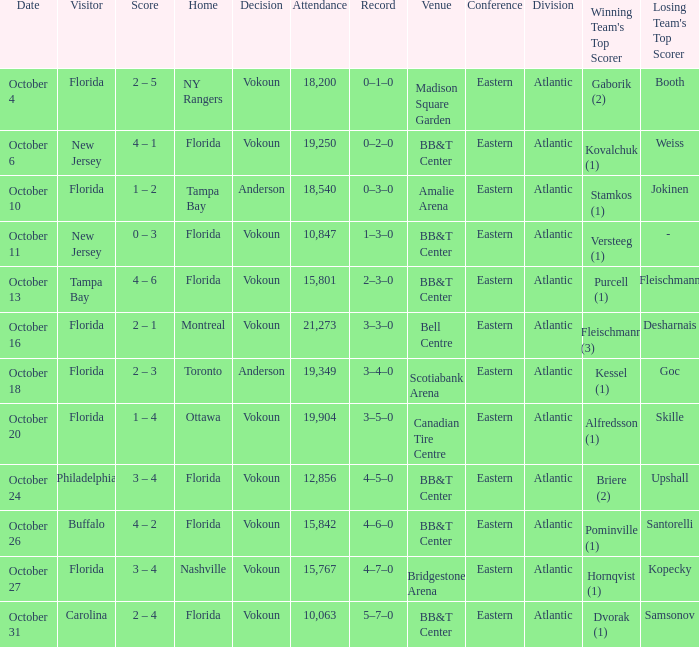Parse the table in full. {'header': ['Date', 'Visitor', 'Score', 'Home', 'Decision', 'Attendance', 'Record', 'Venue', 'Conference', 'Division', "Winning Team's Top Scorer", "Losing Team's Top Scorer"], 'rows': [['October 4', 'Florida', '2 – 5', 'NY Rangers', 'Vokoun', '18,200', '0–1–0', 'Madison Square Garden', 'Eastern', 'Atlantic', 'Gaborik (2)', 'Booth'], ['October 6', 'New Jersey', '4 – 1', 'Florida', 'Vokoun', '19,250', '0–2–0', 'BB&T Center', 'Eastern', 'Atlantic', 'Kovalchuk (1)', 'Weiss'], ['October 10', 'Florida', '1 – 2', 'Tampa Bay', 'Anderson', '18,540', '0–3–0', 'Amalie Arena', 'Eastern', 'Atlantic', 'Stamkos (1)', 'Jokinen'], ['October 11', 'New Jersey', '0 – 3', 'Florida', 'Vokoun', '10,847', '1–3–0', 'BB&T Center', 'Eastern', 'Atlantic', 'Versteeg (1)', '- '], ['October 13', 'Tampa Bay', '4 – 6', 'Florida', 'Vokoun', '15,801', '2–3–0', 'BB&T Center', 'Eastern', 'Atlantic', 'Purcell (1)', 'Fleischmann'], ['October 16', 'Florida', '2 – 1', 'Montreal', 'Vokoun', '21,273', '3–3–0', 'Bell Centre', 'Eastern', 'Atlantic', 'Fleischmann (3)', 'Desharnais'], ['October 18', 'Florida', '2 – 3', 'Toronto', 'Anderson', '19,349', '3–4–0', 'Scotiabank Arena', 'Eastern', 'Atlantic', 'Kessel (1)', 'Goc'], ['October 20', 'Florida', '1 – 4', 'Ottawa', 'Vokoun', '19,904', '3–5–0', 'Canadian Tire Centre', 'Eastern', 'Atlantic', 'Alfredsson (1)', 'Skille'], ['October 24', 'Philadelphia', '3 – 4', 'Florida', 'Vokoun', '12,856', '4–5–0', 'BB&T Center', 'Eastern', 'Atlantic', 'Briere (2)', 'Upshall'], ['October 26', 'Buffalo', '4 – 2', 'Florida', 'Vokoun', '15,842', '4–6–0', 'BB&T Center', 'Eastern', 'Atlantic', 'Pominville (1)', 'Santorelli'], ['October 27', 'Florida', '3 – 4', 'Nashville', 'Vokoun', '15,767', '4–7–0', 'Bridgestone Arena', 'Eastern', 'Atlantic', 'Hornqvist (1)', 'Kopecky'], ['October 31', 'Carolina', '2 – 4', 'Florida', 'Vokoun', '10,063', '5–7–0', 'BB&T Center', 'Eastern', 'Atlantic', 'Dvorak (1)', 'Samsonov']]} Who was the winning team when carolina was the away team? Vokoun. 